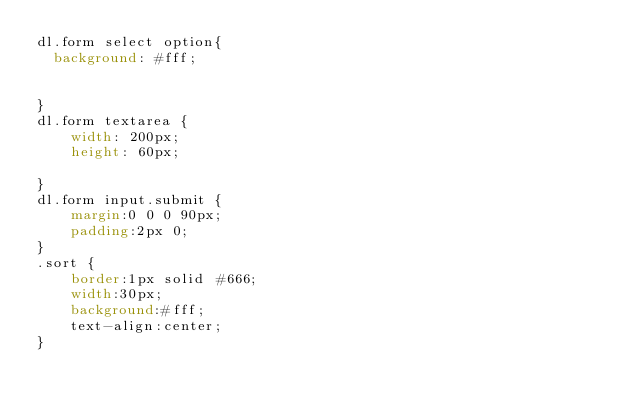Convert code to text. <code><loc_0><loc_0><loc_500><loc_500><_CSS_>dl.form select option{
  background: #fff;


}
dl.form textarea {
    width: 200px;
    height: 60px;

}
dl.form input.submit {
    margin:0 0 0 90px;
    padding:2px 0;
}
.sort {
    border:1px solid #666;
    width:30px;
    background:#fff;
    text-align:center;
}</code> 